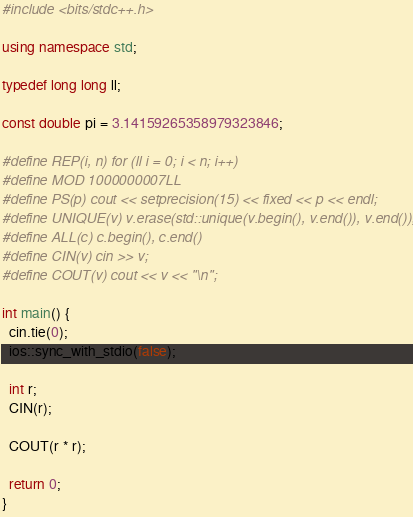<code> <loc_0><loc_0><loc_500><loc_500><_C++_>#include <bits/stdc++.h>

using namespace std;

typedef long long ll;

const double pi = 3.14159265358979323846;

#define REP(i, n) for (ll i = 0; i < n; i++)
#define MOD 1000000007LL
#define PS(p) cout << setprecision(15) << fixed << p << endl;
#define UNIQUE(v) v.erase(std::unique(v.begin(), v.end()), v.end());
#define ALL(c) c.begin(), c.end()
#define CIN(v) cin >> v;
#define COUT(v) cout << v << "\n";

int main() {
  cin.tie(0);
  ios::sync_with_stdio(false);

  int r;
  CIN(r);

  COUT(r * r);

  return 0;
}
</code> 